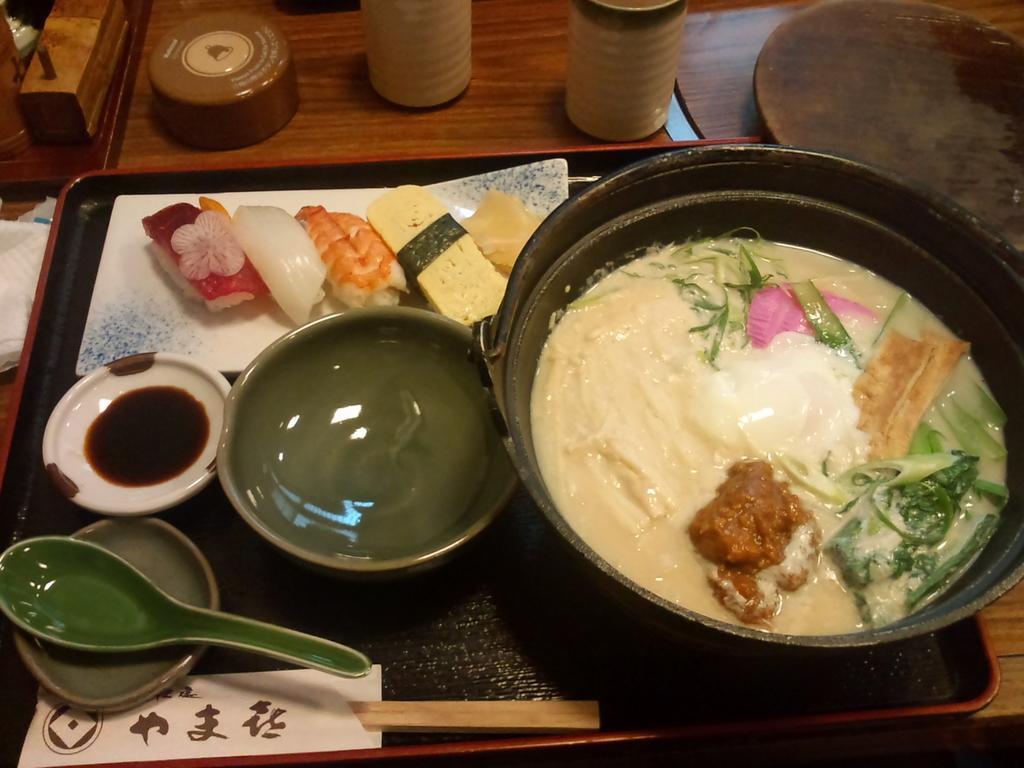Describe this image in one or two sentences. In this picture we can see a table and on table we have tray with bowl, food items, spoon, sticks on it and aside to this we have a tissue paper, caps, some wooden item. 